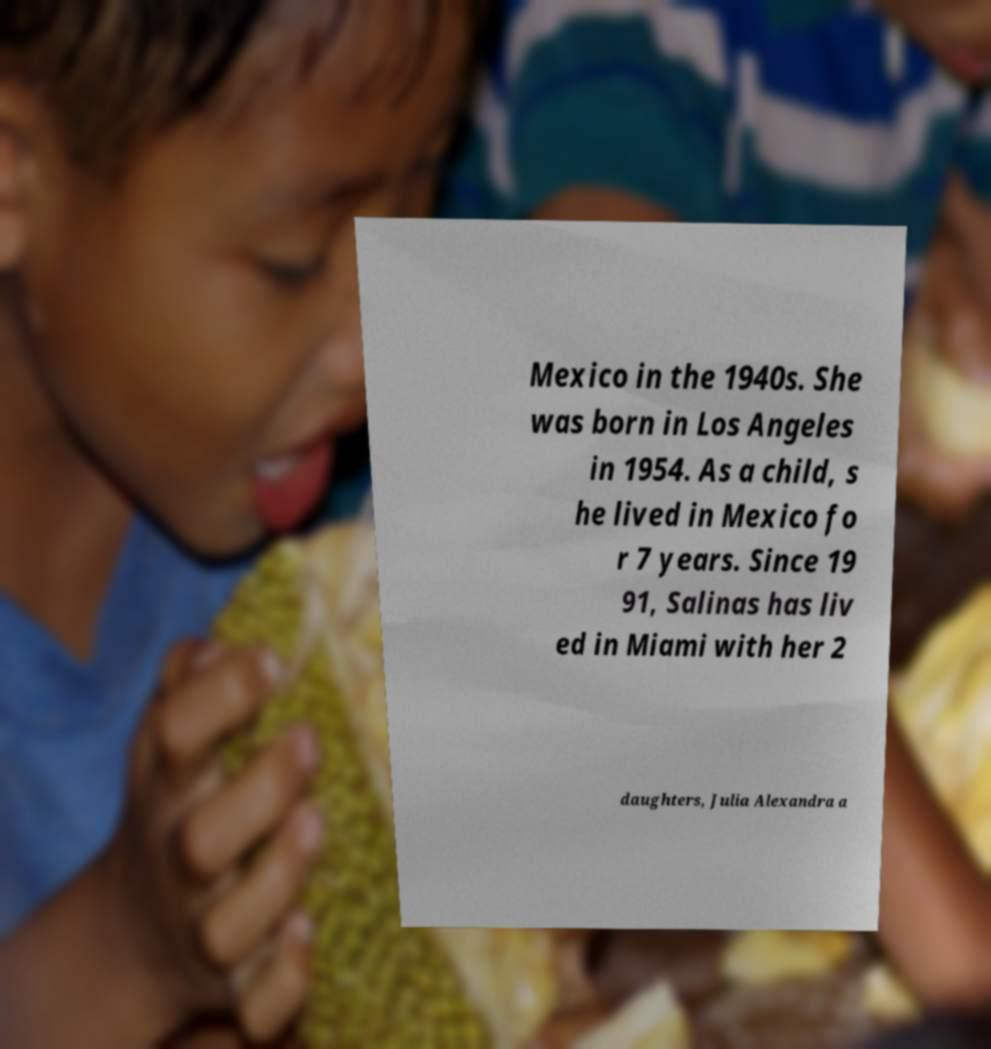For documentation purposes, I need the text within this image transcribed. Could you provide that? Mexico in the 1940s. She was born in Los Angeles in 1954. As a child, s he lived in Mexico fo r 7 years. Since 19 91, Salinas has liv ed in Miami with her 2 daughters, Julia Alexandra a 